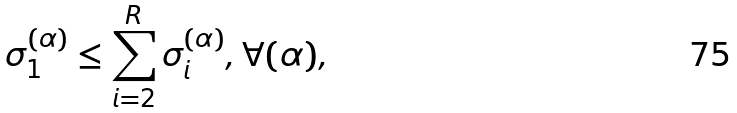<formula> <loc_0><loc_0><loc_500><loc_500>\sigma _ { 1 } ^ { ( \alpha ) } \leq \sum _ { i = 2 } ^ { R } \sigma _ { i } ^ { ( \alpha ) } , \forall ( \alpha ) ,</formula> 